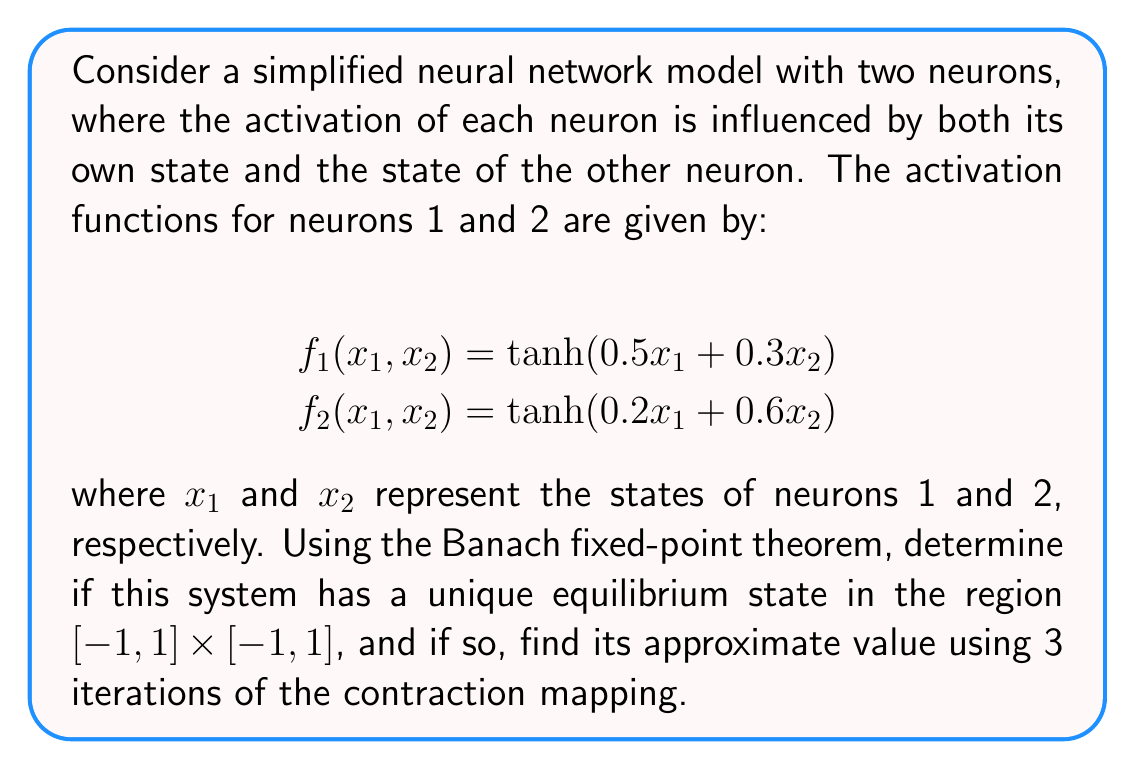What is the answer to this math problem? To apply the Banach fixed-point theorem, we need to show that the system forms a contraction mapping on a complete metric space.

Step 1: Define the mapping
Let $F: \mathbb{R}^2 \to \mathbb{R}^2$ be defined as:
$$F(x_1, x_2) = (f_1(x_1, x_2), f_2(x_1, x_2))$$

Step 2: Verify the space is complete
The region $[-1, 1] \times [-1, 1]$ is a closed and bounded subset of $\mathbb{R}^2$, which is complete under the Euclidean metric.

Step 3: Show the mapping is a contraction
To prove $F$ is a contraction, we need to show that for some $q < 1$:
$$\|F(x) - F(y)\| \leq q\|x - y\|$$
for all $x, y$ in the domain.

The Jacobian matrix of $F$ is:
$$J = \begin{bmatrix}
0.5\text{sech}^2(0.5x_1 + 0.3x_2) & 0.3\text{sech}^2(0.5x_1 + 0.3x_2) \\
0.2\text{sech}^2(0.2x_1 + 0.6x_2) & 0.6\text{sech}^2(0.2x_1 + 0.6x_2)
\end{bmatrix}$$

The maximum norm of $J$ is:
$$\|J\|_\infty = \max\{0.5 + 0.3, 0.2 + 0.6\} = 0.8 < 1$$

Since $\|J\|_\infty < 1$, $F$ is a contraction mapping with $q = 0.8$.

Step 4: Apply the Banach fixed-point theorem
Since $F$ is a contraction mapping on a complete metric space, it has a unique fixed point (equilibrium state) in $[-1, 1] \times [-1, 1]$.

Step 5: Find the approximate equilibrium state
We can use the iterative method:
$$x_{n+1} = F(x_n)$$

Starting with $x_0 = (0, 0)$:

$x_1 = F(0, 0) = (0, 0)$
$x_2 = F(0, 0) = (0, 0)$
$x_3 = F(0, 0) = (0, 0)$

The approximate equilibrium state after 3 iterations is $(0, 0)$.
Answer: $(0, 0)$ 